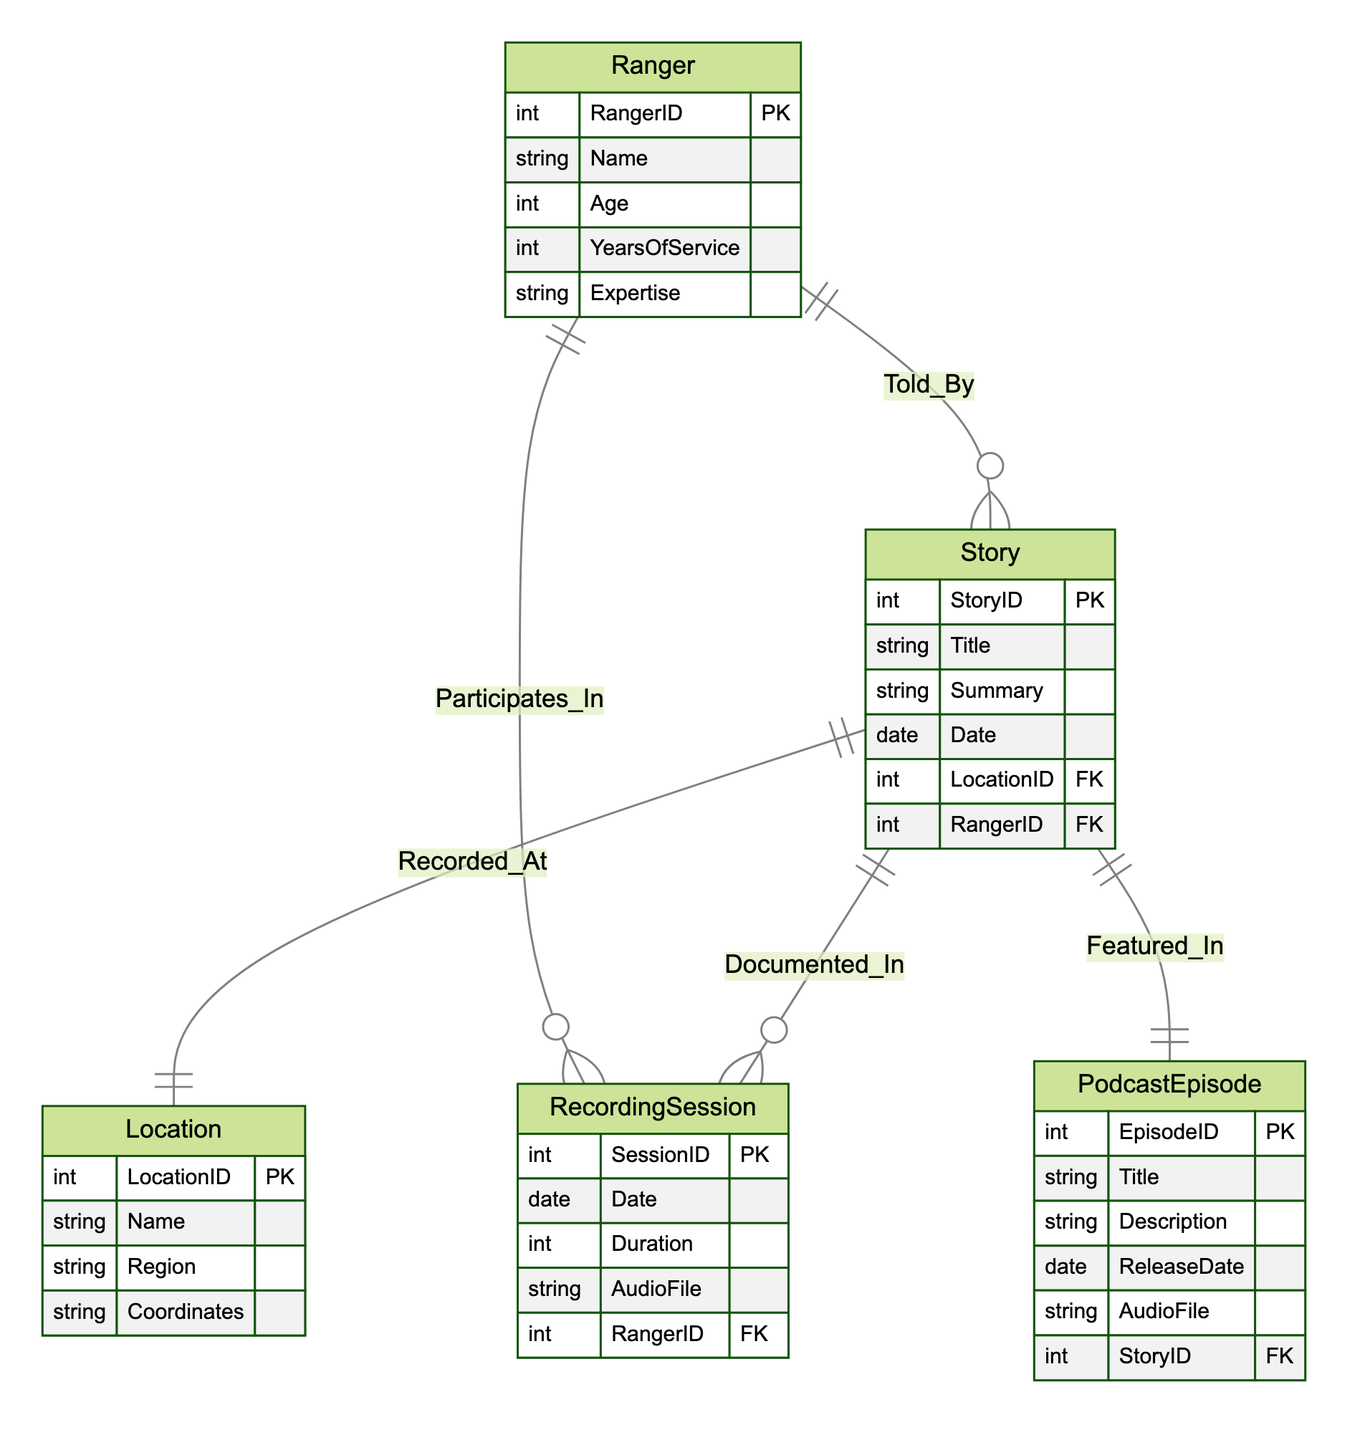What are the attributes of the Ranger entity? The Ranger entity includes five attributes: RangerID, Name, Age, YearsOfService, and Expertise.
Answer: RangerID, Name, Age, YearsOfService, Expertise How many entities are there in the diagram? There are five entities present in the diagram: Ranger, Story, RecordingSession, Location, and PodcastEpisode.
Answer: Five Which entity is connected to the Story entity by a "Told_By" relationship? The Ranger entity is connected to the Story entity by the "Told_By" relationship, indicating that a ranger tells a story.
Answer: Ranger What is the primary key of the Story entity? The primary key of the Story entity is StoryID, which uniquely identifies each story in the database.
Answer: StoryID Which relationship connects the Story and PodcastEpisode entities? The relationship that connects the Story and PodcastEpisode entities is "Featured_In," indicating that a story can be featured in a podcast episode.
Answer: Featured_In What is the minimum number of RecordingSessions for a Story to be documented? A Story can have zero or more RecordingSessions documented in the "Documented_In" relationship, suggesting the minimum is zero.
Answer: Zero Which entity has the coordinates attribute? The Location entity contains the coordinates attribute, which specifies the geographical coordinates of a given location.
Answer: Location How many relationships are shown between the Story and RecordingSession entities? There are two relationships shown between the Story and RecordingSession entities: "Documented_In" and also an implied relationship as a story is documented in each sessions.
Answer: Two What do the connections between the Ranger and RecordingSession entities imply? The connections imply that a Ranger participates in RecordingSessions, meaning that they are the ones who record their stories or experiences during these sessions.
Answer: Participates_In 